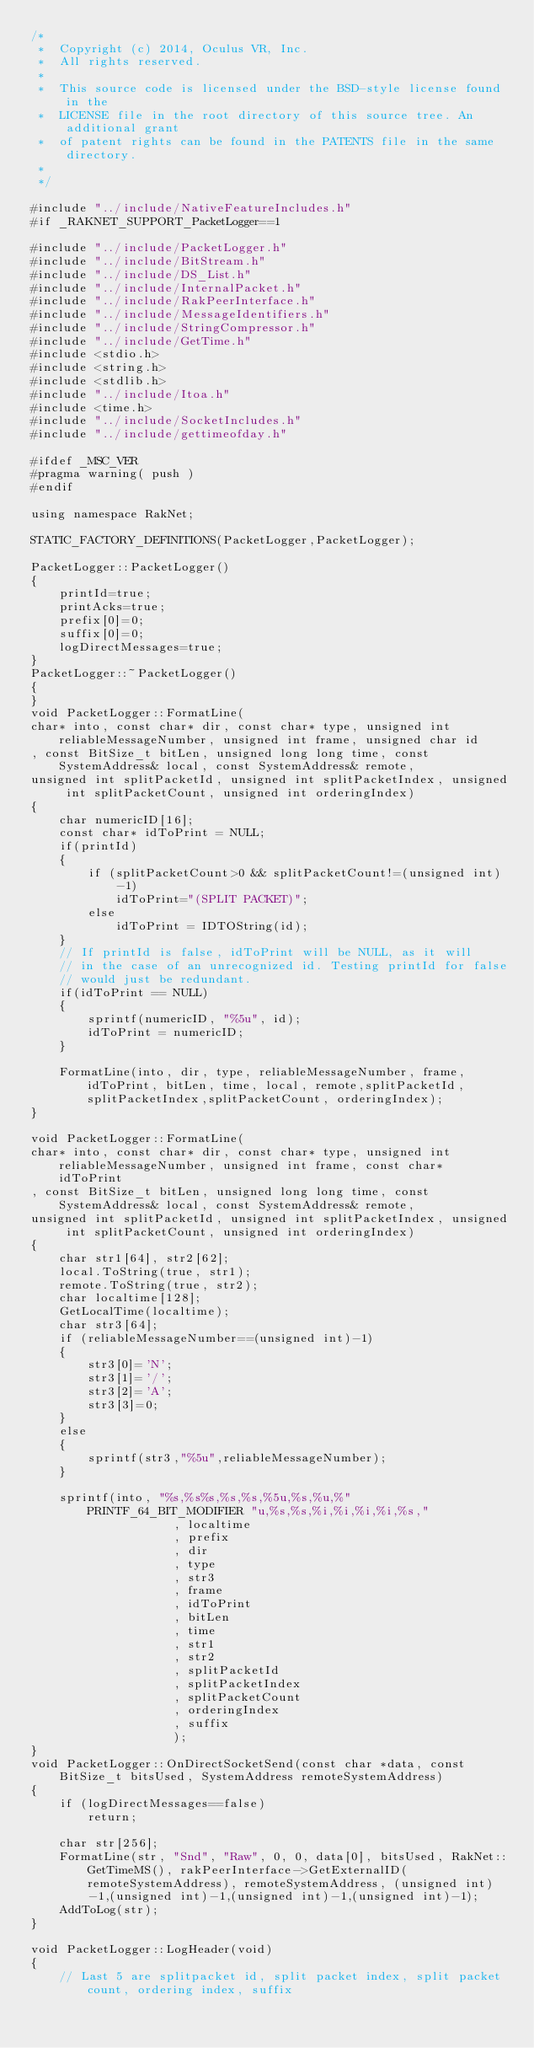Convert code to text. <code><loc_0><loc_0><loc_500><loc_500><_C++_>/*
 *  Copyright (c) 2014, Oculus VR, Inc.
 *  All rights reserved.
 *
 *  This source code is licensed under the BSD-style license found in the
 *  LICENSE file in the root directory of this source tree. An additional grant 
 *  of patent rights can be found in the PATENTS file in the same directory.
 *
 */

#include "../include/NativeFeatureIncludes.h"
#if _RAKNET_SUPPORT_PacketLogger==1

#include "../include/PacketLogger.h"
#include "../include/BitStream.h"
#include "../include/DS_List.h"
#include "../include/InternalPacket.h"
#include "../include/RakPeerInterface.h"
#include "../include/MessageIdentifiers.h"
#include "../include/StringCompressor.h"
#include "../include/GetTime.h"
#include <stdio.h>
#include <string.h>
#include <stdlib.h>
#include "../include/Itoa.h"
#include <time.h>
#include "../include/SocketIncludes.h"
#include "../include/gettimeofday.h"

#ifdef _MSC_VER
#pragma warning( push )
#endif

using namespace RakNet;

STATIC_FACTORY_DEFINITIONS(PacketLogger,PacketLogger);

PacketLogger::PacketLogger()
{
	printId=true;
	printAcks=true;
	prefix[0]=0;
	suffix[0]=0;
	logDirectMessages=true;
}
PacketLogger::~PacketLogger()
{
}
void PacketLogger::FormatLine(
char* into, const char* dir, const char* type, unsigned int reliableMessageNumber, unsigned int frame, unsigned char id
, const BitSize_t bitLen, unsigned long long time, const SystemAddress& local, const SystemAddress& remote,
unsigned int splitPacketId, unsigned int splitPacketIndex, unsigned int splitPacketCount, unsigned int orderingIndex)
{
	char numericID[16];
	const char* idToPrint = NULL;
	if(printId)
	{
		if (splitPacketCount>0 && splitPacketCount!=(unsigned int)-1)
			idToPrint="(SPLIT PACKET)";
		else
			idToPrint =	IDTOString(id);
	}
	// If printId is false, idToPrint will be NULL, as it will
	// in the case of an unrecognized id. Testing printId for false
	// would just be redundant.
	if(idToPrint == NULL)
	{
		sprintf(numericID, "%5u", id);
		idToPrint = numericID;
	}

	FormatLine(into, dir, type, reliableMessageNumber, frame, idToPrint, bitLen, time, local, remote,splitPacketId,splitPacketIndex,splitPacketCount, orderingIndex);
}

void PacketLogger::FormatLine(
char* into, const char* dir, const char* type, unsigned int reliableMessageNumber, unsigned int frame, const char* idToPrint
, const BitSize_t bitLen, unsigned long long time, const SystemAddress& local, const SystemAddress& remote,
unsigned int splitPacketId, unsigned int splitPacketIndex, unsigned int splitPacketCount, unsigned int orderingIndex)
{
	char str1[64], str2[62];
	local.ToString(true, str1);
	remote.ToString(true, str2);
	char localtime[128];
	GetLocalTime(localtime);
	char str3[64];
	if (reliableMessageNumber==(unsigned int)-1)
	{
		str3[0]='N';
		str3[1]='/';
		str3[2]='A';
		str3[3]=0;
	}
	else
	{
		sprintf(str3,"%5u",reliableMessageNumber);
	}

	sprintf(into, "%s,%s%s,%s,%s,%5u,%s,%u,%" PRINTF_64_BIT_MODIFIER "u,%s,%s,%i,%i,%i,%i,%s,"
					, localtime
					, prefix
					, dir
					, type
					, str3
					, frame
					, idToPrint
					, bitLen
					, time
					, str1
					, str2
					, splitPacketId
					, splitPacketIndex
					, splitPacketCount
					, orderingIndex
					, suffix
					);
}
void PacketLogger::OnDirectSocketSend(const char *data, const BitSize_t bitsUsed, SystemAddress remoteSystemAddress)
{
	if (logDirectMessages==false)
		return;

	char str[256];
	FormatLine(str, "Snd", "Raw", 0, 0, data[0], bitsUsed, RakNet::GetTimeMS(), rakPeerInterface->GetExternalID(remoteSystemAddress), remoteSystemAddress, (unsigned int)-1,(unsigned int)-1,(unsigned int)-1,(unsigned int)-1);
	AddToLog(str);
}

void PacketLogger::LogHeader(void)
{
	// Last 5 are splitpacket id, split packet index, split packet count, ordering index, suffix</code> 